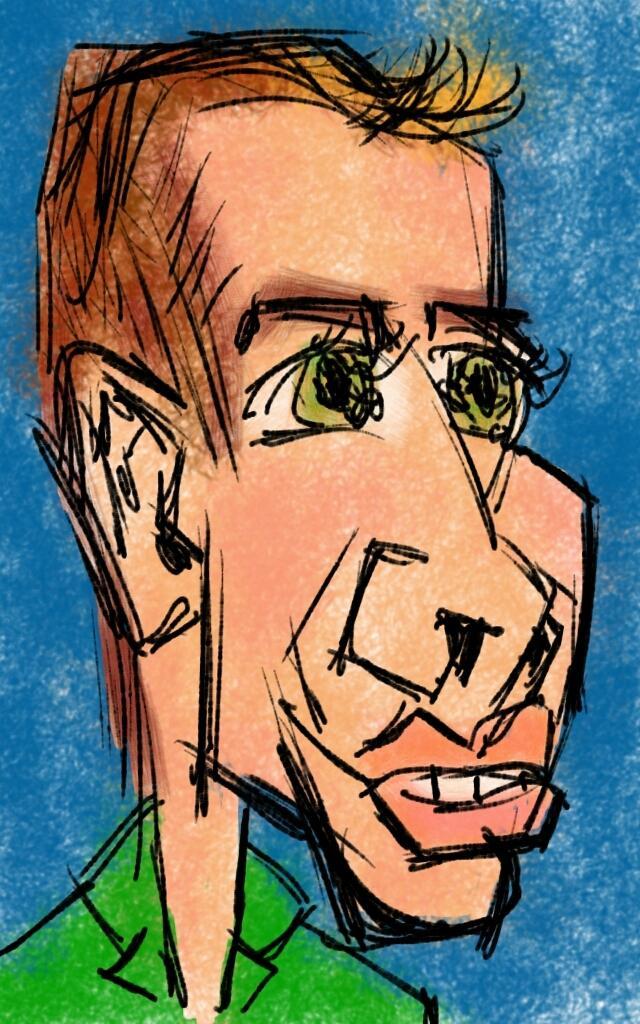How would you summarize this image in a sentence or two? In this image, we can see a cartoon and the background is in blue color. 